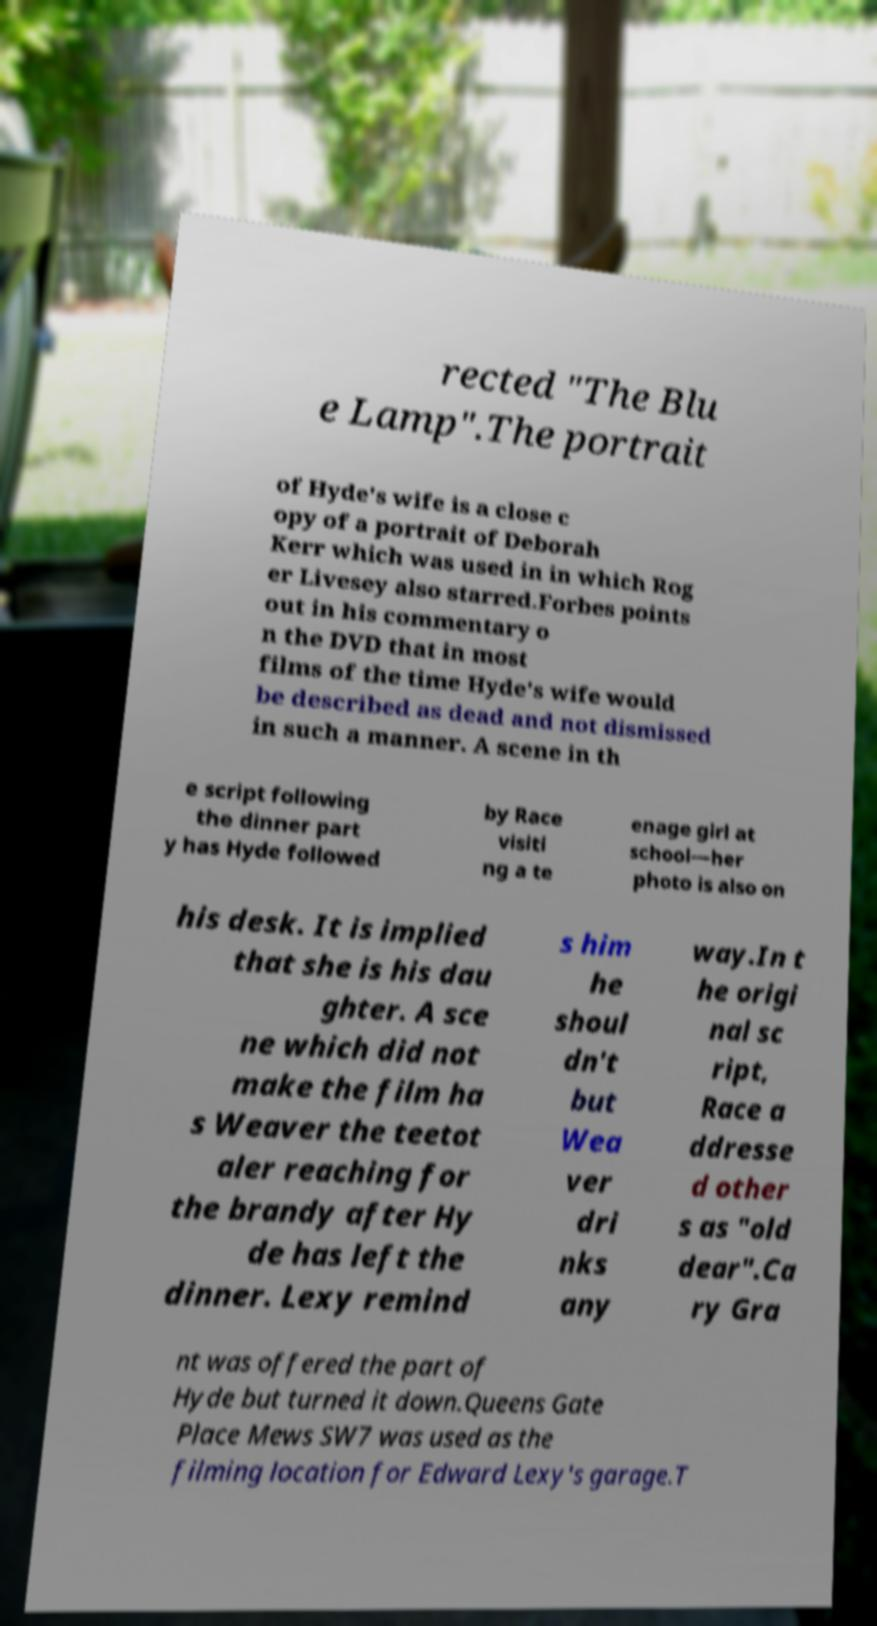Please identify and transcribe the text found in this image. rected "The Blu e Lamp".The portrait of Hyde's wife is a close c opy of a portrait of Deborah Kerr which was used in in which Rog er Livesey also starred.Forbes points out in his commentary o n the DVD that in most films of the time Hyde's wife would be described as dead and not dismissed in such a manner. A scene in th e script following the dinner part y has Hyde followed by Race visiti ng a te enage girl at school—her photo is also on his desk. It is implied that she is his dau ghter. A sce ne which did not make the film ha s Weaver the teetot aler reaching for the brandy after Hy de has left the dinner. Lexy remind s him he shoul dn't but Wea ver dri nks any way.In t he origi nal sc ript, Race a ddresse d other s as "old dear".Ca ry Gra nt was offered the part of Hyde but turned it down.Queens Gate Place Mews SW7 was used as the filming location for Edward Lexy's garage.T 